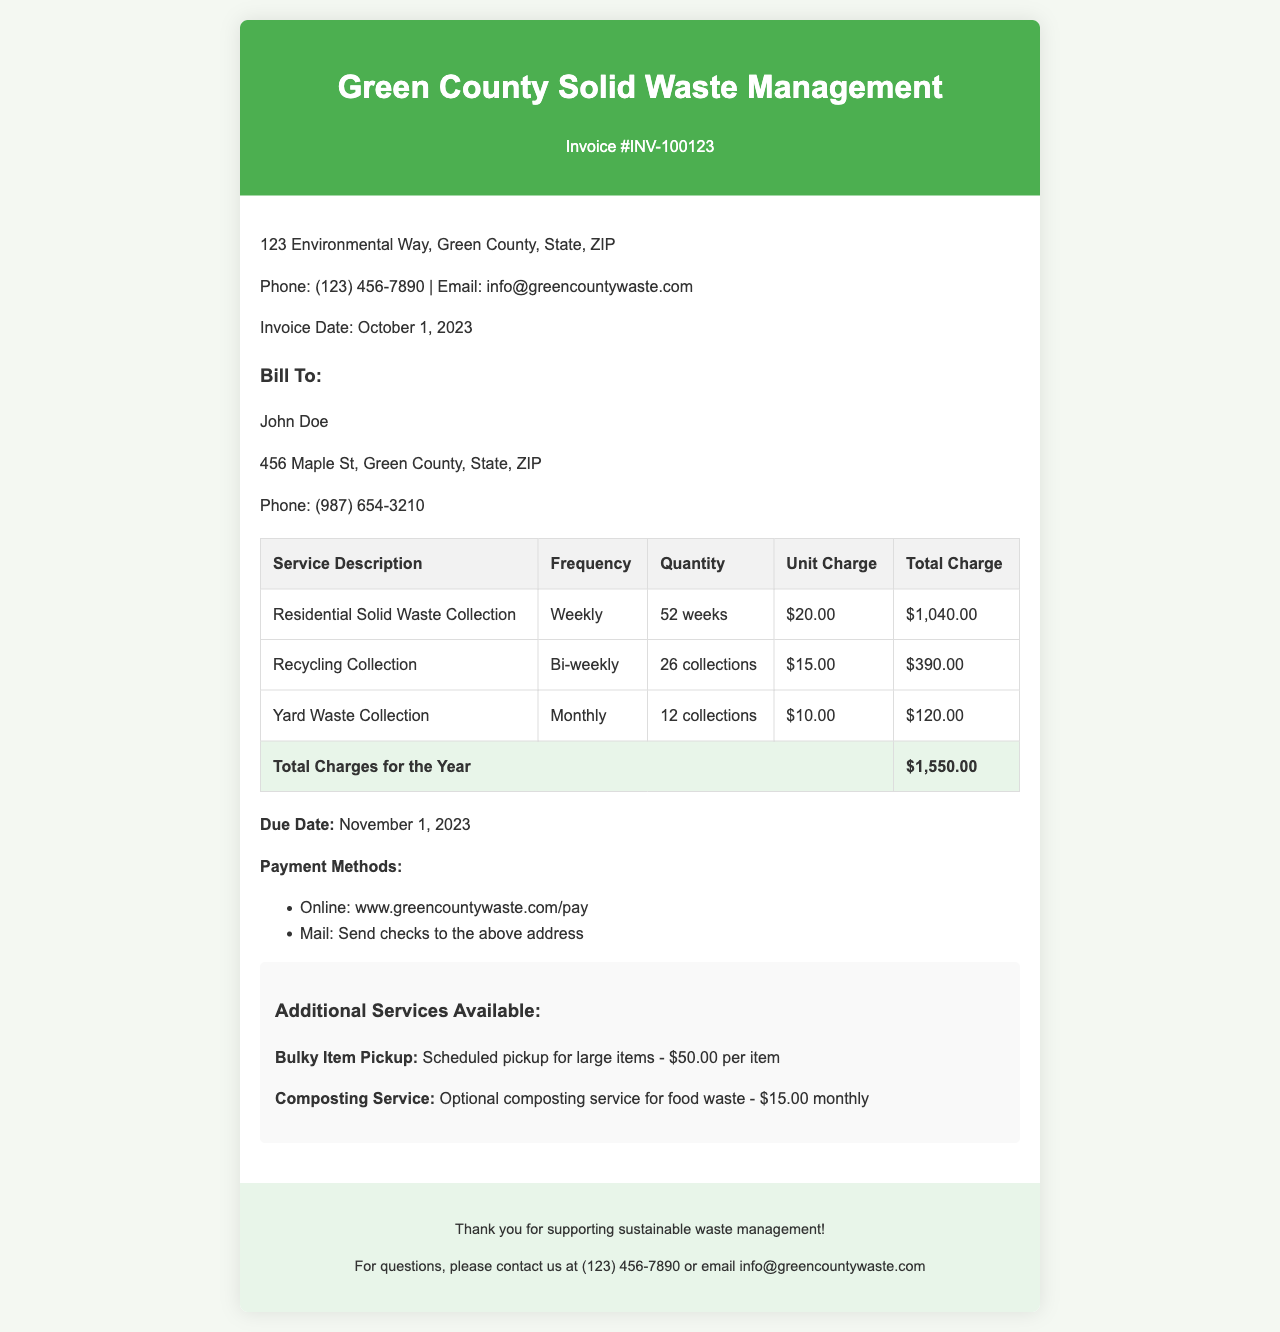what is the invoice number? The invoice number is clearly marked in the header of the document as INV-100123.
Answer: INV-100123 what is the total charge for the year? The total charge for the year is found in the last row of the invoice table, which sums up the total charges of all services.
Answer: $1,550.00 how often is the residential solid waste collected? The frequency for residential solid waste collection is specified in the service description section of the invoice.
Answer: Weekly what is the due date for this invoice? The due date is explicitly stated in the document, under the main body of the invoice.
Answer: November 1, 2023 how many collections are done for recycling service? The number of collections for recycling service is noted in the quantity column of the invoice table.
Answer: 26 collections what is the unit charge for yard waste collection? The unit charge for yard waste collection can be found in the unit charge column of the invoice table related to that service.
Answer: $10.00 what additional service is offered for bulky items? The additional service for bulky items is described in the additional services section at the end of the invoice.
Answer: Bulky Item Pickup what is the monthly charge for composting service? The monthly charge for composting service is detailed in the additional services section of the invoice.
Answer: $15.00 monthly how many weeks in a year does the solid waste collection occur? The number of weeks for solid waste collection is specified in the quantity for residential solid waste collection.
Answer: 52 weeks 